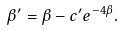Convert formula to latex. <formula><loc_0><loc_0><loc_500><loc_500>\beta ^ { \prime } = \beta - c ^ { \prime } e ^ { - 4 \beta } .</formula> 